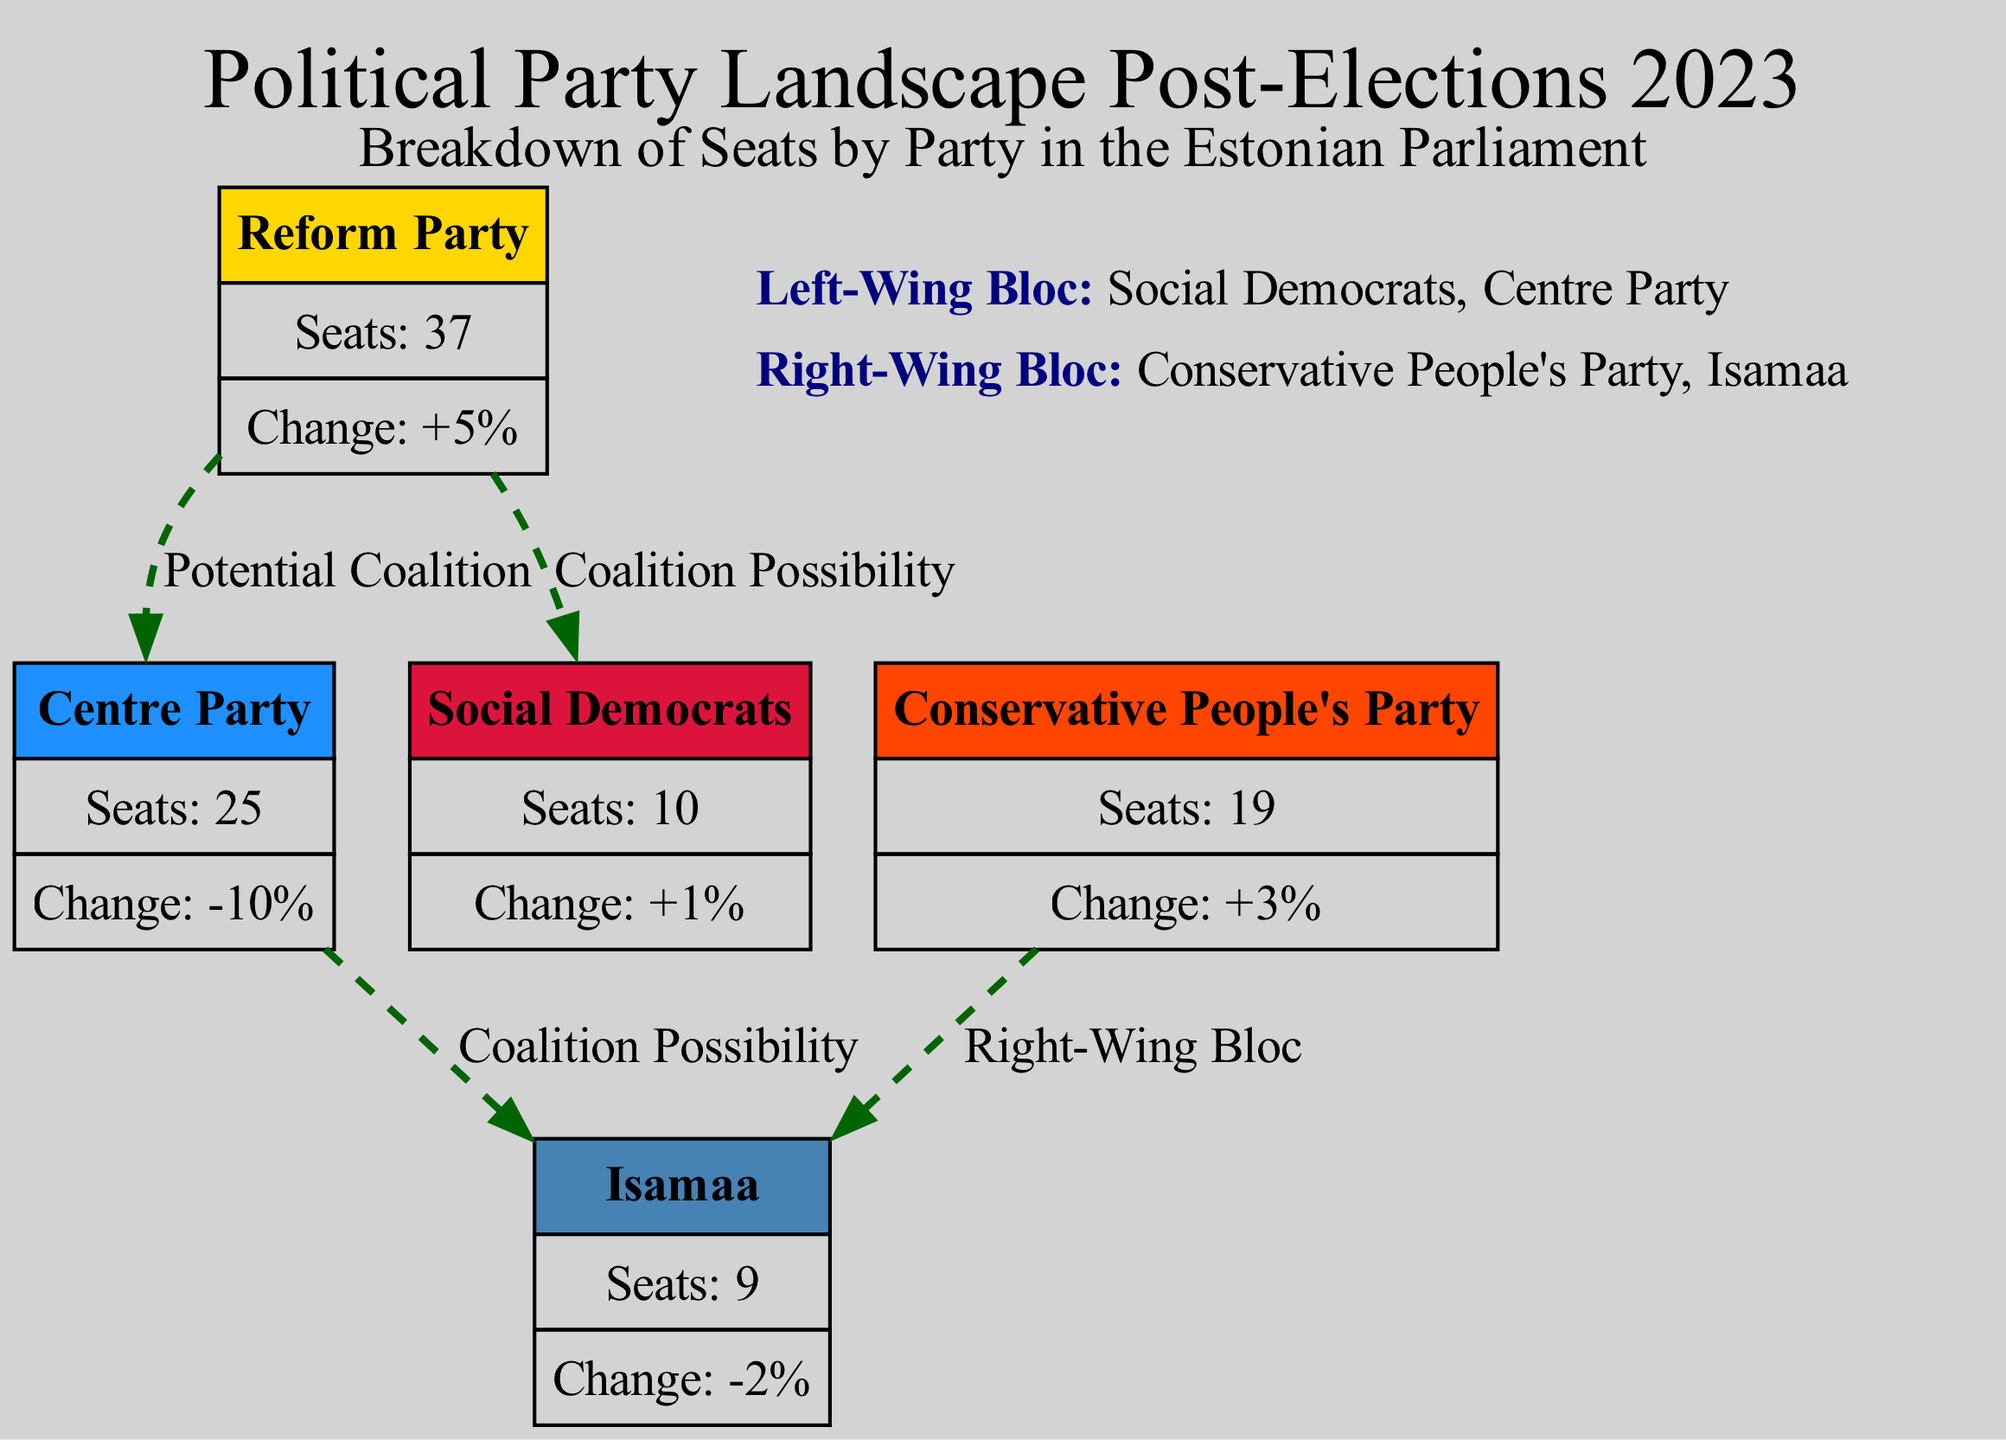What is the total number of seats in the Estonian Parliament according to the diagram? The total number of seats is the sum of the seats held by each political party. Adding the seats held by Reform Party (37), Centre Party (25), Conservative People's Party (19), Social Democrats (10), and Isamaa (9) gives a total of 37 + 25 + 19 + 10 + 9 = 100 seats.
Answer: 100 How many seats did the Centre Party lose since the last election? The Centre Party's change percentage shows a decrease of 10%, indicating it lost seats. However, since they had 25 seats after the election, losing 10% equates to 25 * 0.10 = 2.5, which we round down to 2 seats lost.
Answer: 2 What color represents the Conservative People's Party in the diagram? The Conservative People's Party is represented by the color "#FF4500". This can be found in the node data for the party, which specifies the color associated with it.
Answer: #FF4500 Which parties are included in the Right-Wing Bloc according to the diagram? The Right-Wing Bloc consists of the Conservative People's Party and Isamaa. This information is listed in the key blocs section of the diagram, where the parties are specified.
Answer: Conservative People's Party, Isamaa What is the change percentage for the Social Democrats? The Social Democrats show a change percentage of "+1%", which is explicitly provided in the party's node details regarding their performance relative to the last election.
Answer: +1% Which political party has the highest number of seats? The Reform Party has the highest number of seats, standing at 37. This can be determined by comparing the seat counts in the nodes of the diagram.
Answer: Reform Party What potential coalition does the Centre Party have? The Centre Party has a coalition possibility with Isamaa, as indicated by the dashed edge connecting the Centre Party to Isamaa in the diagram.
Answer: Isamaa Which party did the Reform Party gain seats from? The Reform Party gained seats, shown by the "+5%" change percentage, indicating it improved its standing from the previous election. However, the exact party they gained from isn't specified in the diagram, but overall seat changes can imply losses elsewhere.
Answer: Not specified Which two parties are connected by a dashed line indicating a potential coalition? The parties connected by dashed lines indicating a potential coalition are the Reform Party and the Social Democrats. This is illustrated with edges showing coalition possibilities.
Answer: Reform Party, Social Democrats 